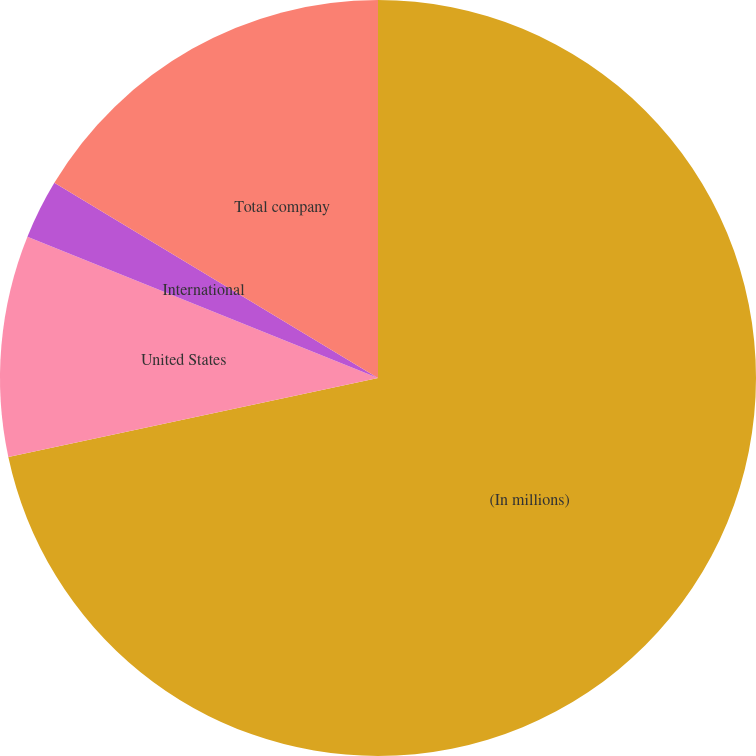<chart> <loc_0><loc_0><loc_500><loc_500><pie_chart><fcel>(In millions)<fcel>United States<fcel>International<fcel>Total company<nl><fcel>71.65%<fcel>9.45%<fcel>2.54%<fcel>16.36%<nl></chart> 